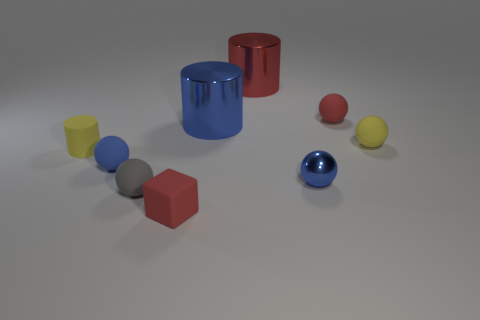How many tiny things are either yellow balls or rubber blocks?
Offer a terse response. 2. Are there more tiny red shiny cubes than large blue metallic cylinders?
Your response must be concise. No. Is the material of the yellow cylinder the same as the red sphere?
Your response must be concise. Yes. Is there any other thing that has the same material as the tiny yellow cylinder?
Your response must be concise. Yes. Are there more small yellow balls in front of the rubber block than tiny blue things?
Ensure brevity in your answer.  No. Does the tiny cube have the same color as the tiny metal sphere?
Your answer should be compact. No. What number of large blue metallic things have the same shape as the tiny shiny thing?
Your answer should be very brief. 0. The red cube that is the same material as the gray sphere is what size?
Offer a terse response. Small. What color is the tiny rubber thing that is in front of the red rubber sphere and to the right of the big blue metallic object?
Ensure brevity in your answer.  Yellow. What number of other metal cubes have the same size as the cube?
Keep it short and to the point. 0. 